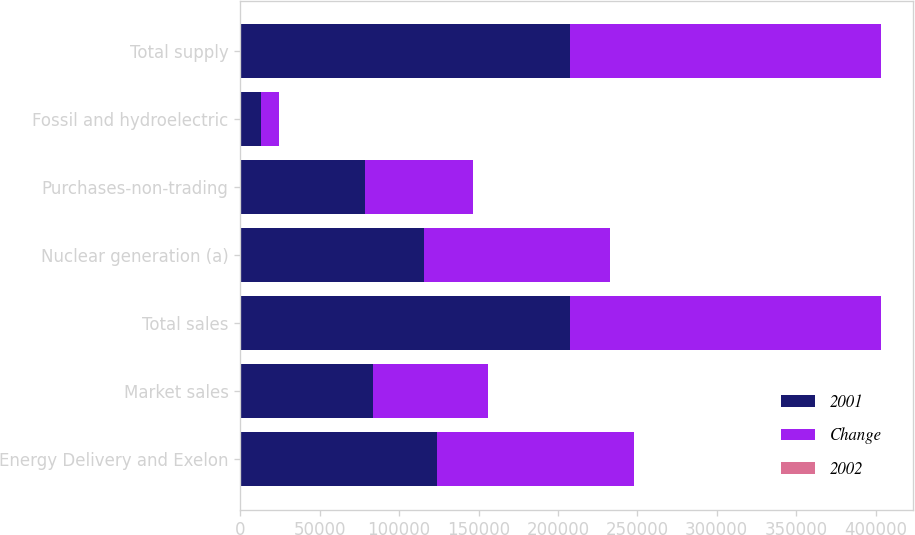Convert chart to OTSL. <chart><loc_0><loc_0><loc_500><loc_500><stacked_bar_chart><ecel><fcel>Energy Delivery and Exelon<fcel>Market sales<fcel>Total sales<fcel>Nuclear generation (a)<fcel>Purchases-non-trading<fcel>Fossil and hydroelectric<fcel>Total supply<nl><fcel>2001<fcel>123975<fcel>83565<fcel>207540<fcel>115854<fcel>78710<fcel>12976<fcel>207540<nl><fcel>Change<fcel>123793<fcel>72333<fcel>196126<fcel>116839<fcel>67942<fcel>11345<fcel>196126<nl><fcel>2002<fcel>0.1<fcel>15.5<fcel>5.8<fcel>0.8<fcel>15.8<fcel>14.4<fcel>5.8<nl></chart> 